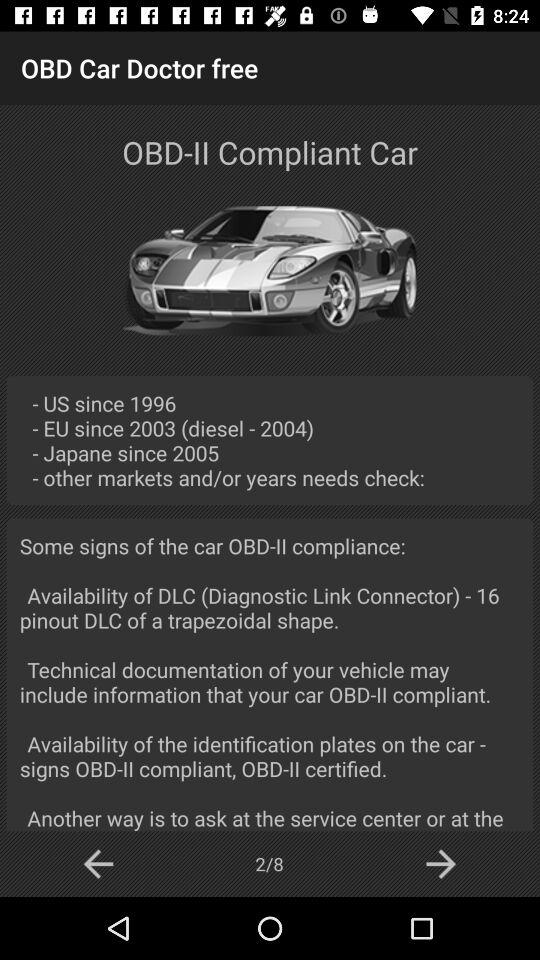What is the name of the application? The name of the application is "OBD Car Doctor free". 